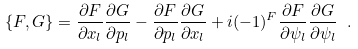Convert formula to latex. <formula><loc_0><loc_0><loc_500><loc_500>\{ F , G \} = \frac { \partial F } { \partial x _ { l } } \frac { \partial G } { \partial p _ { l } } - \frac { \partial F } { \partial p _ { l } } \frac { \partial G } { \partial x _ { l } } + i ( - 1 ) ^ { F } \frac { \partial F } { \partial \psi _ { l } } \frac { \partial G } { \partial \psi _ { l } } \ .</formula> 